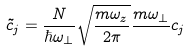<formula> <loc_0><loc_0><loc_500><loc_500>\tilde { c } _ { j } = \frac { N } { \hbar { \omega } _ { \perp } } \sqrt { \frac { m \omega _ { z } } { 2 \pi } } \frac { m \omega _ { \perp } } { } c _ { j }</formula> 